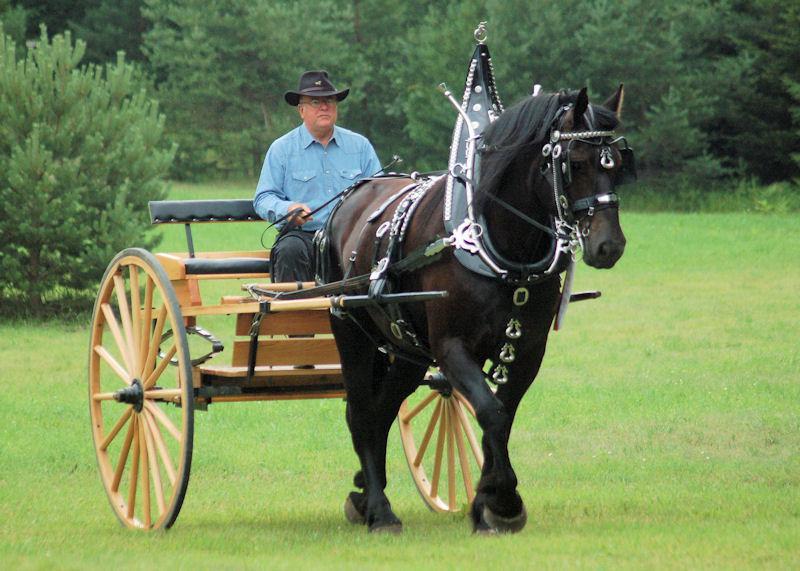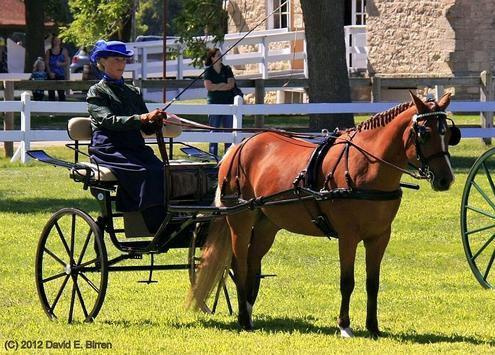The first image is the image on the left, the second image is the image on the right. Evaluate the accuracy of this statement regarding the images: "One cart with two wheels is driven by a man and one by a woman, each holding a whip, to control the single horse.". Is it true? Answer yes or no. Yes. The first image is the image on the left, the second image is the image on the right. Assess this claim about the two images: "In one of the images there is one woman riding in a cart pulled by a horse.". Correct or not? Answer yes or no. Yes. 